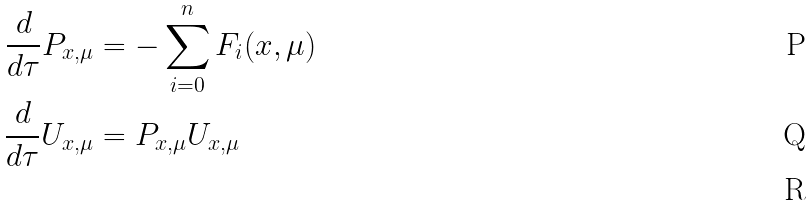<formula> <loc_0><loc_0><loc_500><loc_500>\frac { d } { d \tau } P _ { x , \mu } & = - \sum _ { i = 0 } ^ { n } F _ { i } ( x , \mu ) \\ \frac { d } { d \tau } U _ { x , \mu } & = P _ { x , \mu } U _ { x , \mu } \, \\</formula> 